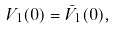<formula> <loc_0><loc_0><loc_500><loc_500>V _ { 1 } ( 0 ) = \bar { V } _ { 1 } ( 0 ) ,</formula> 